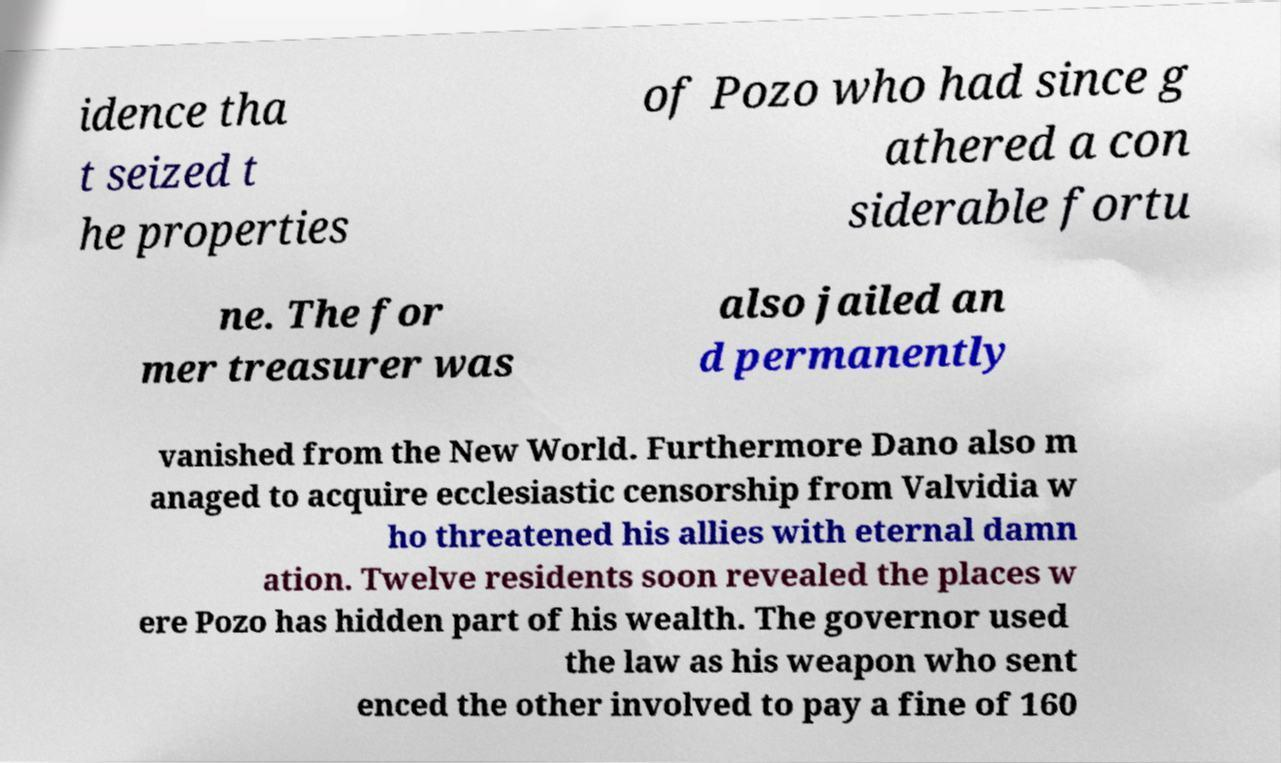For documentation purposes, I need the text within this image transcribed. Could you provide that? idence tha t seized t he properties of Pozo who had since g athered a con siderable fortu ne. The for mer treasurer was also jailed an d permanently vanished from the New World. Furthermore Dano also m anaged to acquire ecclesiastic censorship from Valvidia w ho threatened his allies with eternal damn ation. Twelve residents soon revealed the places w ere Pozo has hidden part of his wealth. The governor used the law as his weapon who sent enced the other involved to pay a fine of 160 